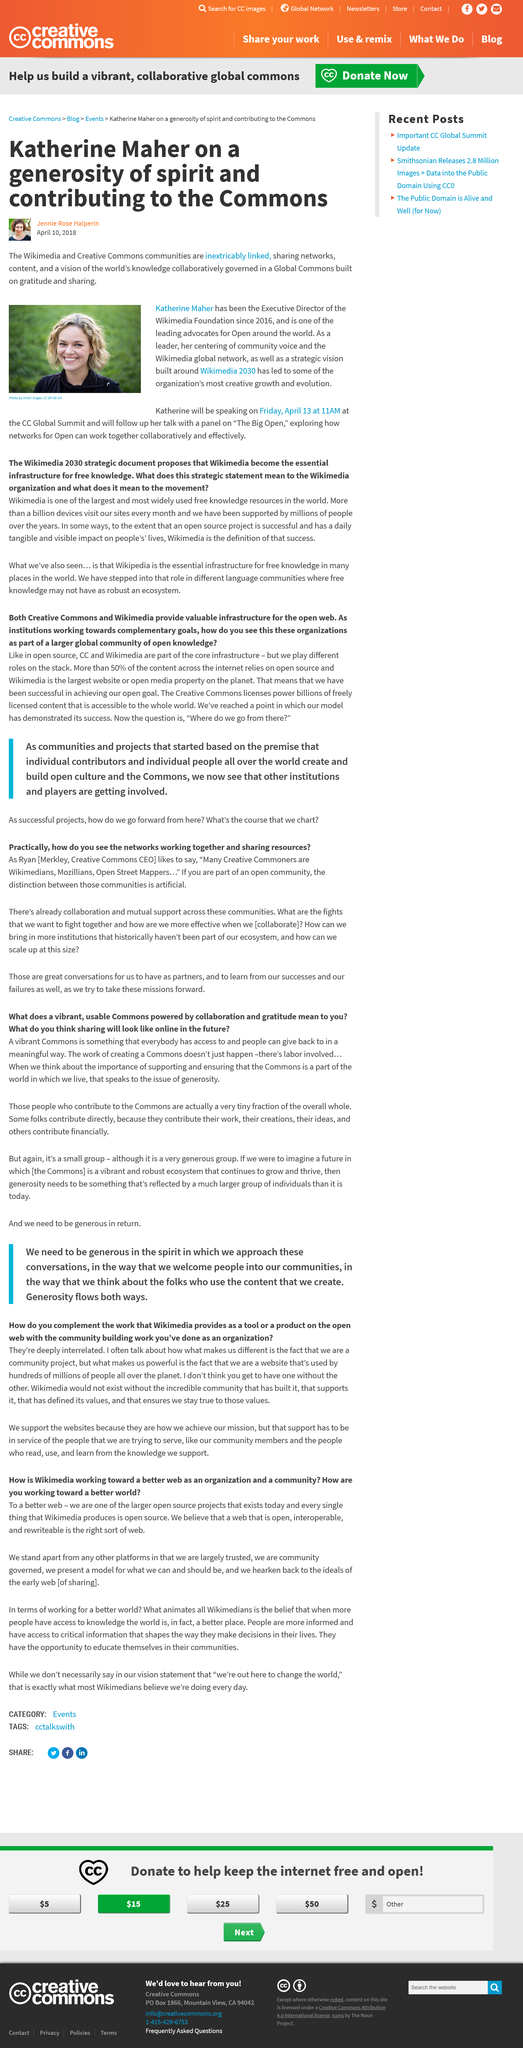Identify some key points in this picture. The girl in the picture is named Katherine Maher. The author of this article is Jenny Rose Halperin. This article was written on April 10th, 2018. 